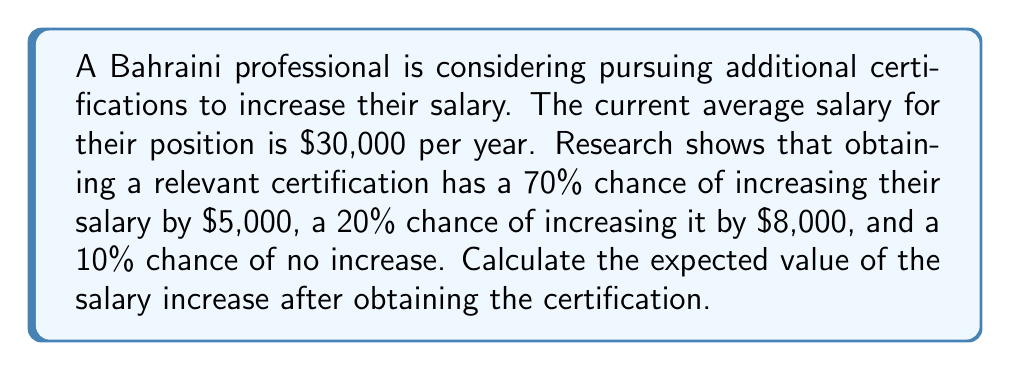Show me your answer to this math problem. To solve this problem, we'll use the concept of expected value for a discrete random variable. The expected value is calculated by multiplying each possible outcome by its probability and then summing these products.

Let's define our random variable X as the salary increase in dollars.

Step 1: Identify the possible outcomes and their probabilities:
- $X = 0$ with probability $P(X = 0) = 0.10$
- $X = 5000$ with probability $P(X = 5000) = 0.70$
- $X = 8000$ with probability $P(X = 8000) = 0.20$

Step 2: Calculate the expected value using the formula:
$$E(X) = \sum_{i=1}^{n} x_i \cdot P(X = x_i)$$

Step 3: Substitute the values:
$$E(X) = 0 \cdot 0.10 + 5000 \cdot 0.70 + 8000 \cdot 0.20$$

Step 4: Perform the calculations:
$$E(X) = 0 + 3500 + 1600 = 5100$$

Therefore, the expected value of the salary increase after obtaining the certification is $5,100.
Answer: $5,100 